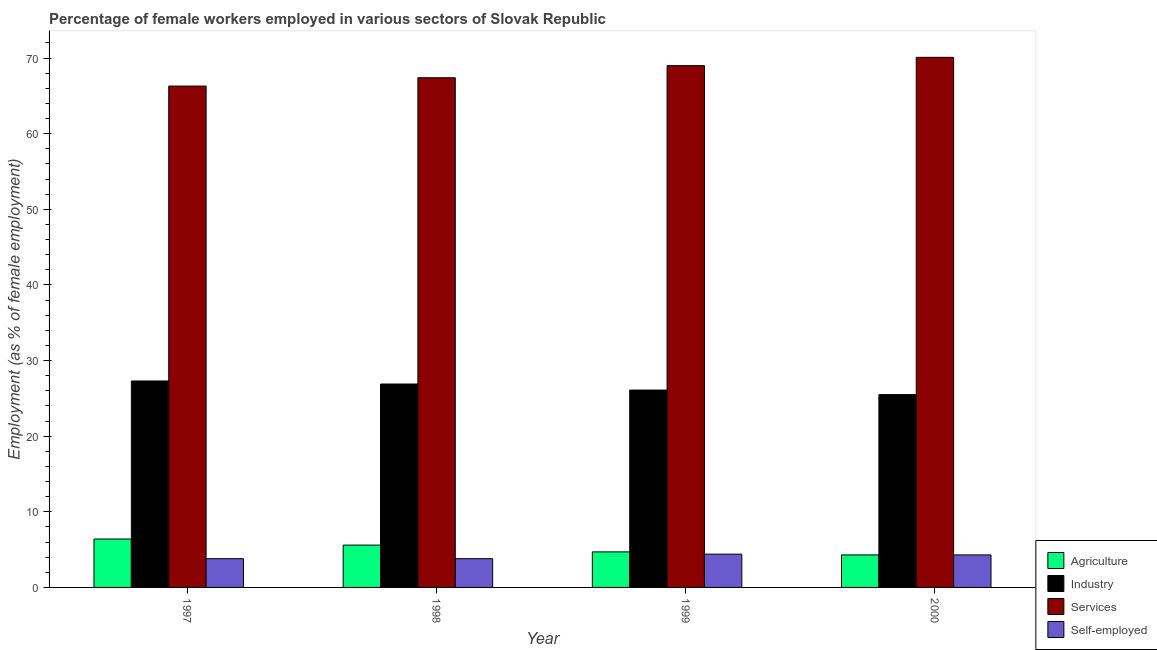How many different coloured bars are there?
Provide a short and direct response. 4. Are the number of bars per tick equal to the number of legend labels?
Give a very brief answer. Yes. Are the number of bars on each tick of the X-axis equal?
Offer a terse response. Yes. What is the label of the 3rd group of bars from the left?
Ensure brevity in your answer.  1999. In how many cases, is the number of bars for a given year not equal to the number of legend labels?
Keep it short and to the point. 0. What is the percentage of female workers in agriculture in 1999?
Provide a short and direct response. 4.7. Across all years, what is the maximum percentage of female workers in industry?
Make the answer very short. 27.3. Across all years, what is the minimum percentage of female workers in agriculture?
Your answer should be compact. 4.3. In which year was the percentage of female workers in agriculture maximum?
Ensure brevity in your answer.  1997. In which year was the percentage of female workers in services minimum?
Your answer should be compact. 1997. What is the total percentage of female workers in agriculture in the graph?
Offer a very short reply. 21. What is the difference between the percentage of self employed female workers in 1998 and that in 1999?
Offer a terse response. -0.6. What is the difference between the percentage of female workers in services in 1997 and the percentage of self employed female workers in 1998?
Keep it short and to the point. -1.1. What is the average percentage of self employed female workers per year?
Your answer should be compact. 4.08. In the year 1999, what is the difference between the percentage of female workers in industry and percentage of self employed female workers?
Ensure brevity in your answer.  0. In how many years, is the percentage of female workers in industry greater than 30 %?
Offer a terse response. 0. What is the ratio of the percentage of female workers in industry in 1997 to that in 1998?
Your answer should be very brief. 1.01. Is the percentage of female workers in services in 1999 less than that in 2000?
Give a very brief answer. Yes. Is the difference between the percentage of female workers in agriculture in 1999 and 2000 greater than the difference between the percentage of female workers in services in 1999 and 2000?
Keep it short and to the point. No. What is the difference between the highest and the second highest percentage of female workers in industry?
Provide a short and direct response. 0.4. What is the difference between the highest and the lowest percentage of female workers in services?
Provide a succinct answer. 3.8. Is the sum of the percentage of self employed female workers in 1997 and 1998 greater than the maximum percentage of female workers in services across all years?
Make the answer very short. Yes. Is it the case that in every year, the sum of the percentage of female workers in agriculture and percentage of female workers in services is greater than the sum of percentage of female workers in industry and percentage of self employed female workers?
Keep it short and to the point. No. What does the 3rd bar from the left in 2000 represents?
Keep it short and to the point. Services. What does the 1st bar from the right in 1998 represents?
Make the answer very short. Self-employed. How many bars are there?
Keep it short and to the point. 16. Are all the bars in the graph horizontal?
Offer a very short reply. No. Are the values on the major ticks of Y-axis written in scientific E-notation?
Provide a succinct answer. No. Does the graph contain any zero values?
Keep it short and to the point. No. Does the graph contain grids?
Provide a succinct answer. No. How are the legend labels stacked?
Keep it short and to the point. Vertical. What is the title of the graph?
Keep it short and to the point. Percentage of female workers employed in various sectors of Slovak Republic. Does "Salary of employees" appear as one of the legend labels in the graph?
Your answer should be compact. No. What is the label or title of the Y-axis?
Offer a very short reply. Employment (as % of female employment). What is the Employment (as % of female employment) of Agriculture in 1997?
Ensure brevity in your answer.  6.4. What is the Employment (as % of female employment) of Industry in 1997?
Your answer should be compact. 27.3. What is the Employment (as % of female employment) in Services in 1997?
Give a very brief answer. 66.3. What is the Employment (as % of female employment) of Self-employed in 1997?
Keep it short and to the point. 3.8. What is the Employment (as % of female employment) of Agriculture in 1998?
Your answer should be very brief. 5.6. What is the Employment (as % of female employment) of Industry in 1998?
Give a very brief answer. 26.9. What is the Employment (as % of female employment) of Services in 1998?
Your answer should be very brief. 67.4. What is the Employment (as % of female employment) in Self-employed in 1998?
Offer a terse response. 3.8. What is the Employment (as % of female employment) in Agriculture in 1999?
Your answer should be compact. 4.7. What is the Employment (as % of female employment) in Industry in 1999?
Offer a very short reply. 26.1. What is the Employment (as % of female employment) of Self-employed in 1999?
Keep it short and to the point. 4.4. What is the Employment (as % of female employment) in Agriculture in 2000?
Give a very brief answer. 4.3. What is the Employment (as % of female employment) of Industry in 2000?
Offer a very short reply. 25.5. What is the Employment (as % of female employment) of Services in 2000?
Provide a short and direct response. 70.1. What is the Employment (as % of female employment) in Self-employed in 2000?
Your response must be concise. 4.3. Across all years, what is the maximum Employment (as % of female employment) in Agriculture?
Make the answer very short. 6.4. Across all years, what is the maximum Employment (as % of female employment) of Industry?
Ensure brevity in your answer.  27.3. Across all years, what is the maximum Employment (as % of female employment) in Services?
Offer a very short reply. 70.1. Across all years, what is the maximum Employment (as % of female employment) of Self-employed?
Make the answer very short. 4.4. Across all years, what is the minimum Employment (as % of female employment) in Agriculture?
Your answer should be compact. 4.3. Across all years, what is the minimum Employment (as % of female employment) in Services?
Your answer should be compact. 66.3. Across all years, what is the minimum Employment (as % of female employment) in Self-employed?
Make the answer very short. 3.8. What is the total Employment (as % of female employment) in Industry in the graph?
Your response must be concise. 105.8. What is the total Employment (as % of female employment) of Services in the graph?
Make the answer very short. 272.8. What is the difference between the Employment (as % of female employment) of Industry in 1997 and that in 1998?
Your response must be concise. 0.4. What is the difference between the Employment (as % of female employment) in Self-employed in 1997 and that in 1998?
Offer a terse response. 0. What is the difference between the Employment (as % of female employment) in Industry in 1997 and that in 1999?
Provide a short and direct response. 1.2. What is the difference between the Employment (as % of female employment) of Self-employed in 1997 and that in 1999?
Make the answer very short. -0.6. What is the difference between the Employment (as % of female employment) in Agriculture in 1997 and that in 2000?
Keep it short and to the point. 2.1. What is the difference between the Employment (as % of female employment) of Self-employed in 1997 and that in 2000?
Your answer should be compact. -0.5. What is the difference between the Employment (as % of female employment) in Services in 1998 and that in 1999?
Keep it short and to the point. -1.6. What is the difference between the Employment (as % of female employment) of Agriculture in 1998 and that in 2000?
Give a very brief answer. 1.3. What is the difference between the Employment (as % of female employment) in Agriculture in 1999 and that in 2000?
Keep it short and to the point. 0.4. What is the difference between the Employment (as % of female employment) in Services in 1999 and that in 2000?
Offer a terse response. -1.1. What is the difference between the Employment (as % of female employment) of Self-employed in 1999 and that in 2000?
Your response must be concise. 0.1. What is the difference between the Employment (as % of female employment) of Agriculture in 1997 and the Employment (as % of female employment) of Industry in 1998?
Ensure brevity in your answer.  -20.5. What is the difference between the Employment (as % of female employment) of Agriculture in 1997 and the Employment (as % of female employment) of Services in 1998?
Ensure brevity in your answer.  -61. What is the difference between the Employment (as % of female employment) in Industry in 1997 and the Employment (as % of female employment) in Services in 1998?
Your response must be concise. -40.1. What is the difference between the Employment (as % of female employment) of Industry in 1997 and the Employment (as % of female employment) of Self-employed in 1998?
Your answer should be very brief. 23.5. What is the difference between the Employment (as % of female employment) in Services in 1997 and the Employment (as % of female employment) in Self-employed in 1998?
Keep it short and to the point. 62.5. What is the difference between the Employment (as % of female employment) in Agriculture in 1997 and the Employment (as % of female employment) in Industry in 1999?
Your answer should be compact. -19.7. What is the difference between the Employment (as % of female employment) of Agriculture in 1997 and the Employment (as % of female employment) of Services in 1999?
Offer a very short reply. -62.6. What is the difference between the Employment (as % of female employment) in Industry in 1997 and the Employment (as % of female employment) in Services in 1999?
Your answer should be very brief. -41.7. What is the difference between the Employment (as % of female employment) in Industry in 1997 and the Employment (as % of female employment) in Self-employed in 1999?
Your answer should be compact. 22.9. What is the difference between the Employment (as % of female employment) in Services in 1997 and the Employment (as % of female employment) in Self-employed in 1999?
Keep it short and to the point. 61.9. What is the difference between the Employment (as % of female employment) of Agriculture in 1997 and the Employment (as % of female employment) of Industry in 2000?
Offer a very short reply. -19.1. What is the difference between the Employment (as % of female employment) in Agriculture in 1997 and the Employment (as % of female employment) in Services in 2000?
Offer a very short reply. -63.7. What is the difference between the Employment (as % of female employment) in Industry in 1997 and the Employment (as % of female employment) in Services in 2000?
Give a very brief answer. -42.8. What is the difference between the Employment (as % of female employment) of Services in 1997 and the Employment (as % of female employment) of Self-employed in 2000?
Offer a very short reply. 62. What is the difference between the Employment (as % of female employment) of Agriculture in 1998 and the Employment (as % of female employment) of Industry in 1999?
Your answer should be compact. -20.5. What is the difference between the Employment (as % of female employment) of Agriculture in 1998 and the Employment (as % of female employment) of Services in 1999?
Give a very brief answer. -63.4. What is the difference between the Employment (as % of female employment) of Agriculture in 1998 and the Employment (as % of female employment) of Self-employed in 1999?
Offer a very short reply. 1.2. What is the difference between the Employment (as % of female employment) of Industry in 1998 and the Employment (as % of female employment) of Services in 1999?
Ensure brevity in your answer.  -42.1. What is the difference between the Employment (as % of female employment) of Agriculture in 1998 and the Employment (as % of female employment) of Industry in 2000?
Give a very brief answer. -19.9. What is the difference between the Employment (as % of female employment) of Agriculture in 1998 and the Employment (as % of female employment) of Services in 2000?
Ensure brevity in your answer.  -64.5. What is the difference between the Employment (as % of female employment) of Agriculture in 1998 and the Employment (as % of female employment) of Self-employed in 2000?
Make the answer very short. 1.3. What is the difference between the Employment (as % of female employment) of Industry in 1998 and the Employment (as % of female employment) of Services in 2000?
Ensure brevity in your answer.  -43.2. What is the difference between the Employment (as % of female employment) in Industry in 1998 and the Employment (as % of female employment) in Self-employed in 2000?
Offer a very short reply. 22.6. What is the difference between the Employment (as % of female employment) of Services in 1998 and the Employment (as % of female employment) of Self-employed in 2000?
Make the answer very short. 63.1. What is the difference between the Employment (as % of female employment) in Agriculture in 1999 and the Employment (as % of female employment) in Industry in 2000?
Your answer should be compact. -20.8. What is the difference between the Employment (as % of female employment) of Agriculture in 1999 and the Employment (as % of female employment) of Services in 2000?
Give a very brief answer. -65.4. What is the difference between the Employment (as % of female employment) in Agriculture in 1999 and the Employment (as % of female employment) in Self-employed in 2000?
Keep it short and to the point. 0.4. What is the difference between the Employment (as % of female employment) in Industry in 1999 and the Employment (as % of female employment) in Services in 2000?
Offer a terse response. -44. What is the difference between the Employment (as % of female employment) in Industry in 1999 and the Employment (as % of female employment) in Self-employed in 2000?
Your response must be concise. 21.8. What is the difference between the Employment (as % of female employment) of Services in 1999 and the Employment (as % of female employment) of Self-employed in 2000?
Give a very brief answer. 64.7. What is the average Employment (as % of female employment) in Agriculture per year?
Provide a short and direct response. 5.25. What is the average Employment (as % of female employment) of Industry per year?
Your response must be concise. 26.45. What is the average Employment (as % of female employment) in Services per year?
Give a very brief answer. 68.2. What is the average Employment (as % of female employment) in Self-employed per year?
Offer a very short reply. 4.08. In the year 1997, what is the difference between the Employment (as % of female employment) in Agriculture and Employment (as % of female employment) in Industry?
Ensure brevity in your answer.  -20.9. In the year 1997, what is the difference between the Employment (as % of female employment) in Agriculture and Employment (as % of female employment) in Services?
Your answer should be compact. -59.9. In the year 1997, what is the difference between the Employment (as % of female employment) in Industry and Employment (as % of female employment) in Services?
Your answer should be compact. -39. In the year 1997, what is the difference between the Employment (as % of female employment) of Industry and Employment (as % of female employment) of Self-employed?
Ensure brevity in your answer.  23.5. In the year 1997, what is the difference between the Employment (as % of female employment) in Services and Employment (as % of female employment) in Self-employed?
Provide a short and direct response. 62.5. In the year 1998, what is the difference between the Employment (as % of female employment) of Agriculture and Employment (as % of female employment) of Industry?
Your response must be concise. -21.3. In the year 1998, what is the difference between the Employment (as % of female employment) in Agriculture and Employment (as % of female employment) in Services?
Make the answer very short. -61.8. In the year 1998, what is the difference between the Employment (as % of female employment) in Industry and Employment (as % of female employment) in Services?
Offer a terse response. -40.5. In the year 1998, what is the difference between the Employment (as % of female employment) of Industry and Employment (as % of female employment) of Self-employed?
Your answer should be very brief. 23.1. In the year 1998, what is the difference between the Employment (as % of female employment) in Services and Employment (as % of female employment) in Self-employed?
Keep it short and to the point. 63.6. In the year 1999, what is the difference between the Employment (as % of female employment) of Agriculture and Employment (as % of female employment) of Industry?
Offer a very short reply. -21.4. In the year 1999, what is the difference between the Employment (as % of female employment) in Agriculture and Employment (as % of female employment) in Services?
Provide a succinct answer. -64.3. In the year 1999, what is the difference between the Employment (as % of female employment) in Agriculture and Employment (as % of female employment) in Self-employed?
Keep it short and to the point. 0.3. In the year 1999, what is the difference between the Employment (as % of female employment) in Industry and Employment (as % of female employment) in Services?
Your answer should be very brief. -42.9. In the year 1999, what is the difference between the Employment (as % of female employment) in Industry and Employment (as % of female employment) in Self-employed?
Ensure brevity in your answer.  21.7. In the year 1999, what is the difference between the Employment (as % of female employment) in Services and Employment (as % of female employment) in Self-employed?
Keep it short and to the point. 64.6. In the year 2000, what is the difference between the Employment (as % of female employment) in Agriculture and Employment (as % of female employment) in Industry?
Make the answer very short. -21.2. In the year 2000, what is the difference between the Employment (as % of female employment) in Agriculture and Employment (as % of female employment) in Services?
Provide a succinct answer. -65.8. In the year 2000, what is the difference between the Employment (as % of female employment) in Industry and Employment (as % of female employment) in Services?
Make the answer very short. -44.6. In the year 2000, what is the difference between the Employment (as % of female employment) of Industry and Employment (as % of female employment) of Self-employed?
Make the answer very short. 21.2. In the year 2000, what is the difference between the Employment (as % of female employment) of Services and Employment (as % of female employment) of Self-employed?
Your answer should be very brief. 65.8. What is the ratio of the Employment (as % of female employment) of Agriculture in 1997 to that in 1998?
Make the answer very short. 1.14. What is the ratio of the Employment (as % of female employment) of Industry in 1997 to that in 1998?
Offer a terse response. 1.01. What is the ratio of the Employment (as % of female employment) in Services in 1997 to that in 1998?
Keep it short and to the point. 0.98. What is the ratio of the Employment (as % of female employment) of Agriculture in 1997 to that in 1999?
Give a very brief answer. 1.36. What is the ratio of the Employment (as % of female employment) of Industry in 1997 to that in 1999?
Give a very brief answer. 1.05. What is the ratio of the Employment (as % of female employment) of Services in 1997 to that in 1999?
Keep it short and to the point. 0.96. What is the ratio of the Employment (as % of female employment) in Self-employed in 1997 to that in 1999?
Your answer should be compact. 0.86. What is the ratio of the Employment (as % of female employment) of Agriculture in 1997 to that in 2000?
Give a very brief answer. 1.49. What is the ratio of the Employment (as % of female employment) in Industry in 1997 to that in 2000?
Your response must be concise. 1.07. What is the ratio of the Employment (as % of female employment) in Services in 1997 to that in 2000?
Ensure brevity in your answer.  0.95. What is the ratio of the Employment (as % of female employment) of Self-employed in 1997 to that in 2000?
Your answer should be very brief. 0.88. What is the ratio of the Employment (as % of female employment) of Agriculture in 1998 to that in 1999?
Your answer should be compact. 1.19. What is the ratio of the Employment (as % of female employment) in Industry in 1998 to that in 1999?
Offer a terse response. 1.03. What is the ratio of the Employment (as % of female employment) of Services in 1998 to that in 1999?
Offer a terse response. 0.98. What is the ratio of the Employment (as % of female employment) in Self-employed in 1998 to that in 1999?
Offer a terse response. 0.86. What is the ratio of the Employment (as % of female employment) in Agriculture in 1998 to that in 2000?
Your answer should be compact. 1.3. What is the ratio of the Employment (as % of female employment) in Industry in 1998 to that in 2000?
Ensure brevity in your answer.  1.05. What is the ratio of the Employment (as % of female employment) of Services in 1998 to that in 2000?
Your answer should be very brief. 0.96. What is the ratio of the Employment (as % of female employment) of Self-employed in 1998 to that in 2000?
Offer a very short reply. 0.88. What is the ratio of the Employment (as % of female employment) of Agriculture in 1999 to that in 2000?
Keep it short and to the point. 1.09. What is the ratio of the Employment (as % of female employment) of Industry in 1999 to that in 2000?
Your answer should be very brief. 1.02. What is the ratio of the Employment (as % of female employment) in Services in 1999 to that in 2000?
Offer a very short reply. 0.98. What is the ratio of the Employment (as % of female employment) in Self-employed in 1999 to that in 2000?
Make the answer very short. 1.02. What is the difference between the highest and the second highest Employment (as % of female employment) in Agriculture?
Offer a very short reply. 0.8. What is the difference between the highest and the lowest Employment (as % of female employment) in Industry?
Keep it short and to the point. 1.8. 